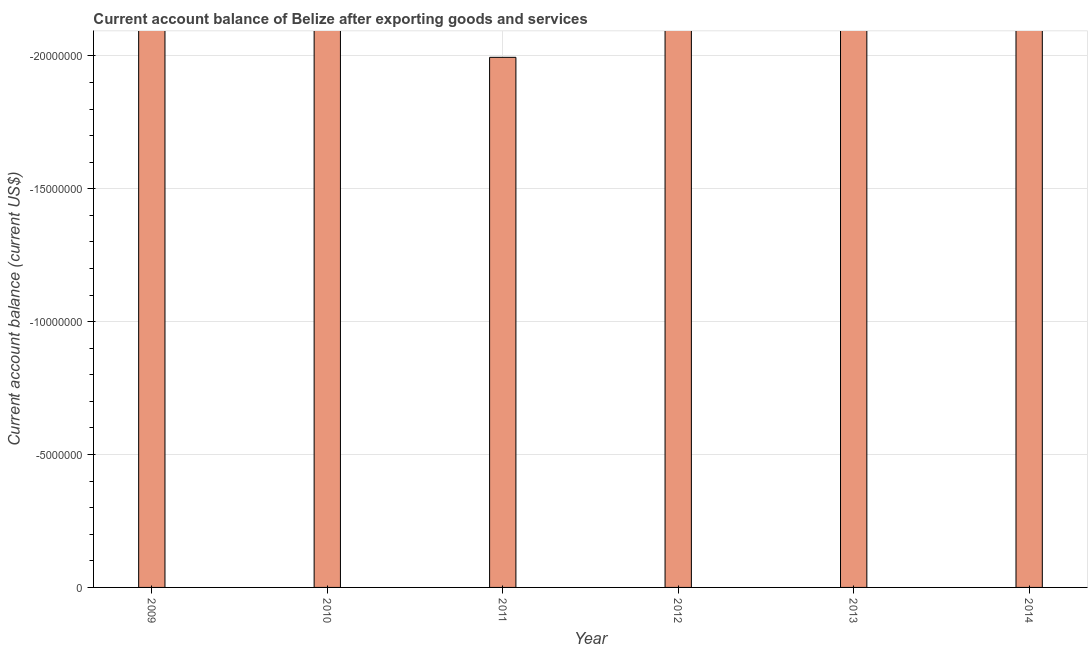What is the title of the graph?
Ensure brevity in your answer.  Current account balance of Belize after exporting goods and services. What is the label or title of the X-axis?
Ensure brevity in your answer.  Year. What is the label or title of the Y-axis?
Your response must be concise. Current account balance (current US$). What is the current account balance in 2011?
Provide a succinct answer. 0. What is the average current account balance per year?
Provide a short and direct response. 0. In how many years, is the current account balance greater than -10000000 US$?
Provide a short and direct response. 0. How many bars are there?
Ensure brevity in your answer.  0. What is the Current account balance (current US$) of 2010?
Provide a short and direct response. 0. What is the Current account balance (current US$) in 2013?
Give a very brief answer. 0. 